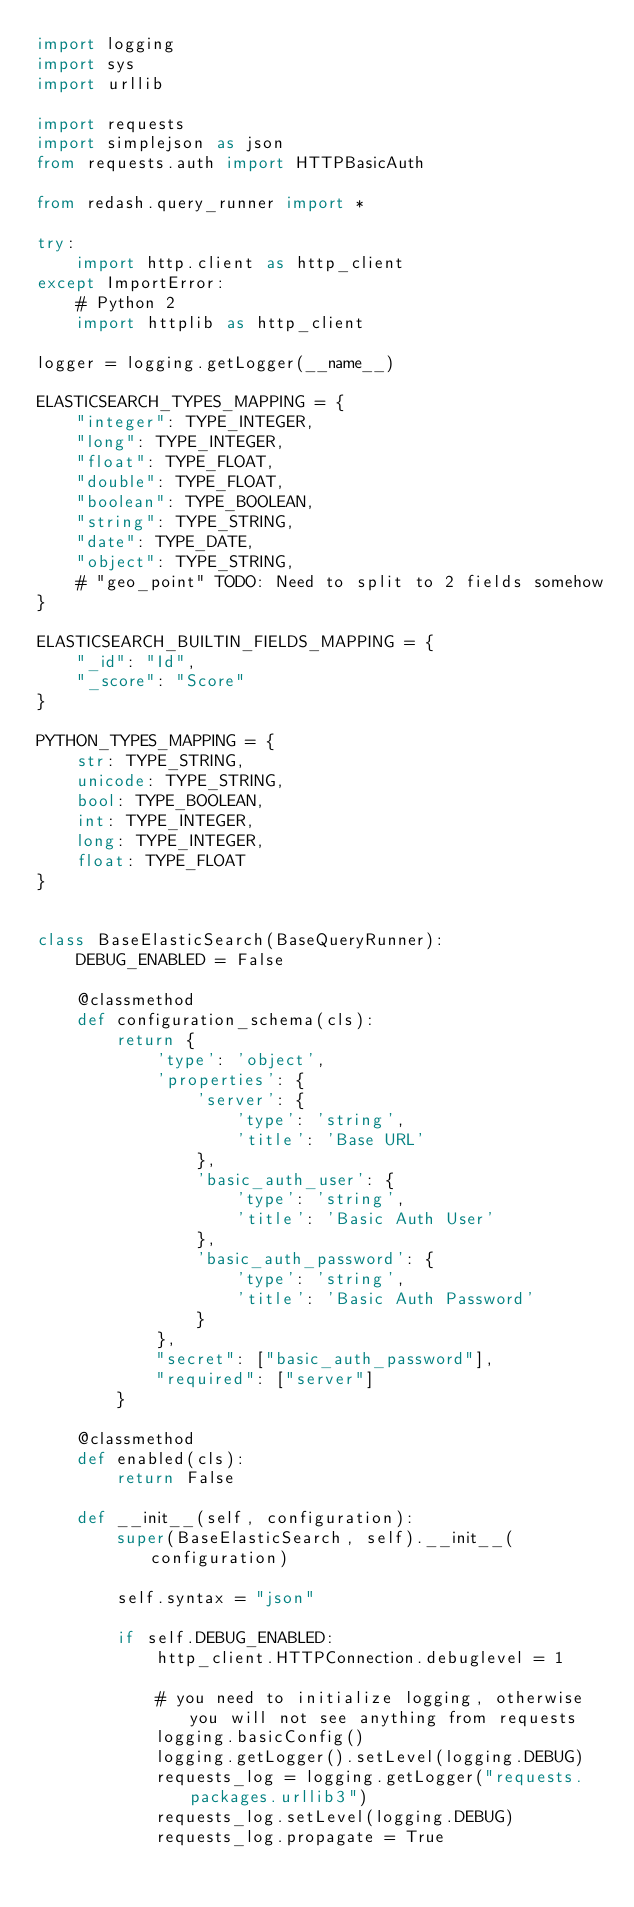<code> <loc_0><loc_0><loc_500><loc_500><_Python_>import logging
import sys
import urllib

import requests
import simplejson as json
from requests.auth import HTTPBasicAuth

from redash.query_runner import *

try:
    import http.client as http_client
except ImportError:
    # Python 2
    import httplib as http_client

logger = logging.getLogger(__name__)

ELASTICSEARCH_TYPES_MAPPING = {
    "integer": TYPE_INTEGER,
    "long": TYPE_INTEGER,
    "float": TYPE_FLOAT,
    "double": TYPE_FLOAT,
    "boolean": TYPE_BOOLEAN,
    "string": TYPE_STRING,
    "date": TYPE_DATE,
    "object": TYPE_STRING,
    # "geo_point" TODO: Need to split to 2 fields somehow
}

ELASTICSEARCH_BUILTIN_FIELDS_MAPPING = {
    "_id": "Id",
    "_score": "Score"
}

PYTHON_TYPES_MAPPING = {
    str: TYPE_STRING,
    unicode: TYPE_STRING,
    bool: TYPE_BOOLEAN,
    int: TYPE_INTEGER,
    long: TYPE_INTEGER,
    float: TYPE_FLOAT
}


class BaseElasticSearch(BaseQueryRunner):
    DEBUG_ENABLED = False

    @classmethod
    def configuration_schema(cls):
        return {
            'type': 'object',
            'properties': {
                'server': {
                    'type': 'string',
                    'title': 'Base URL'
                },
                'basic_auth_user': {
                    'type': 'string',
                    'title': 'Basic Auth User'
                },
                'basic_auth_password': {
                    'type': 'string',
                    'title': 'Basic Auth Password'
                }
            },
            "secret": ["basic_auth_password"],
            "required": ["server"]
        }

    @classmethod
    def enabled(cls):
        return False

    def __init__(self, configuration):
        super(BaseElasticSearch, self).__init__(configuration)

        self.syntax = "json"

        if self.DEBUG_ENABLED:
            http_client.HTTPConnection.debuglevel = 1

            # you need to initialize logging, otherwise you will not see anything from requests
            logging.basicConfig()
            logging.getLogger().setLevel(logging.DEBUG)
            requests_log = logging.getLogger("requests.packages.urllib3")
            requests_log.setLevel(logging.DEBUG)
            requests_log.propagate = True
</code> 